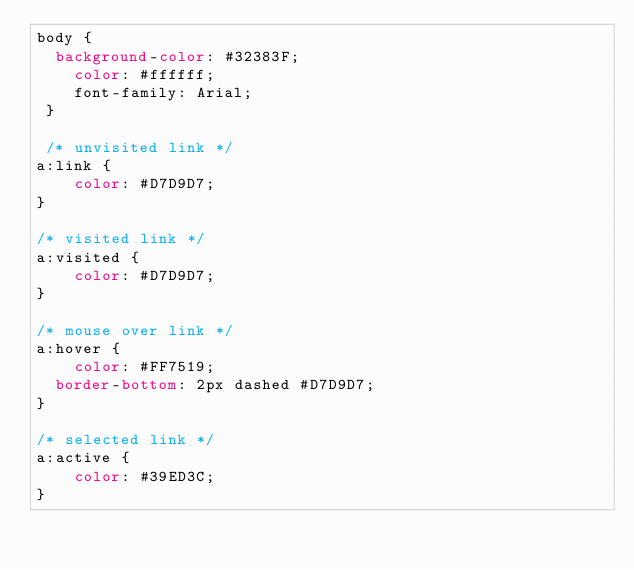Convert code to text. <code><loc_0><loc_0><loc_500><loc_500><_CSS_>body {
	background-color: #32383F;
    color: #ffffff;
    font-family: Arial;
 }
 
 /* unvisited link */
a:link {
    color: #D7D9D7;
}

/* visited link */
a:visited {
    color: #D7D9D7;
}

/* mouse over link */
a:hover {
    color: #FF7519;
	border-bottom: 2px dashed #D7D9D7;
}

/* selected link */
a:active {
    color: #39ED3C;
}</code> 